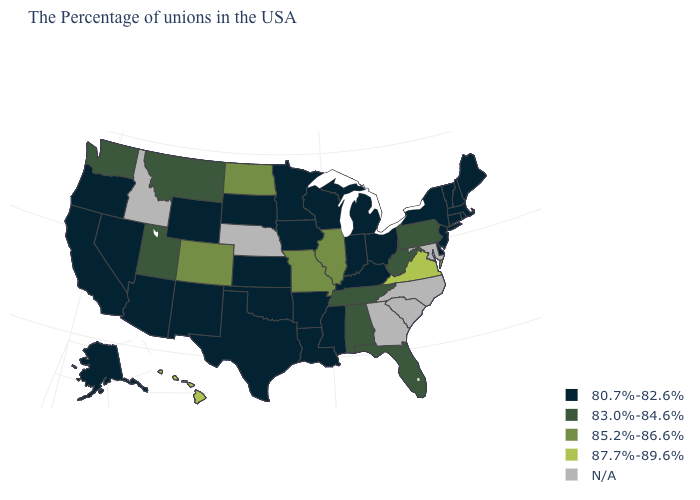What is the value of Ohio?
Answer briefly. 80.7%-82.6%. Is the legend a continuous bar?
Give a very brief answer. No. What is the value of Hawaii?
Keep it brief. 87.7%-89.6%. What is the value of Washington?
Give a very brief answer. 83.0%-84.6%. Among the states that border Iowa , does Illinois have the lowest value?
Quick response, please. No. How many symbols are there in the legend?
Concise answer only. 5. What is the lowest value in states that border Maryland?
Answer briefly. 80.7%-82.6%. What is the lowest value in the MidWest?
Short answer required. 80.7%-82.6%. What is the highest value in the West ?
Answer briefly. 87.7%-89.6%. What is the lowest value in the Northeast?
Give a very brief answer. 80.7%-82.6%. What is the value of Maine?
Give a very brief answer. 80.7%-82.6%. 